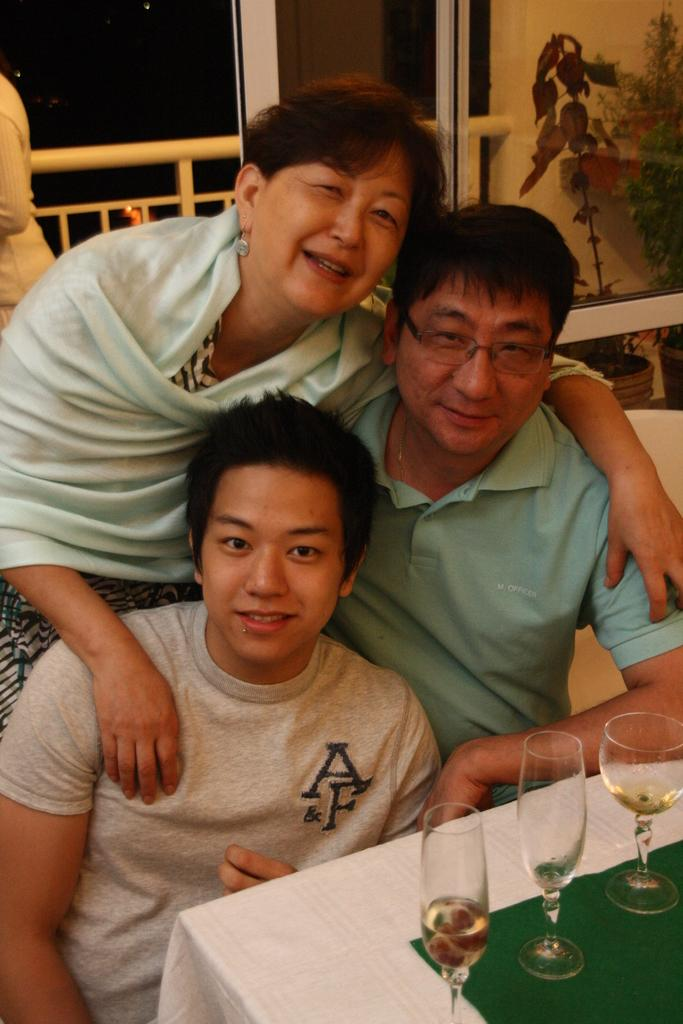How many people are in the image? There is a group of persons in the image. What is present on the table in the image? There is a wine glass on the table. What type of door can be seen in the image? There is a glass door in the image. What can be found near the glass door? There is a flower pot in the image. What type of guitar is being played by the judge in the image? There is no judge or guitar present in the image. What activity are the people in the image participating in? The provided facts do not specify any particular activity that the group of persons is engaged in. 